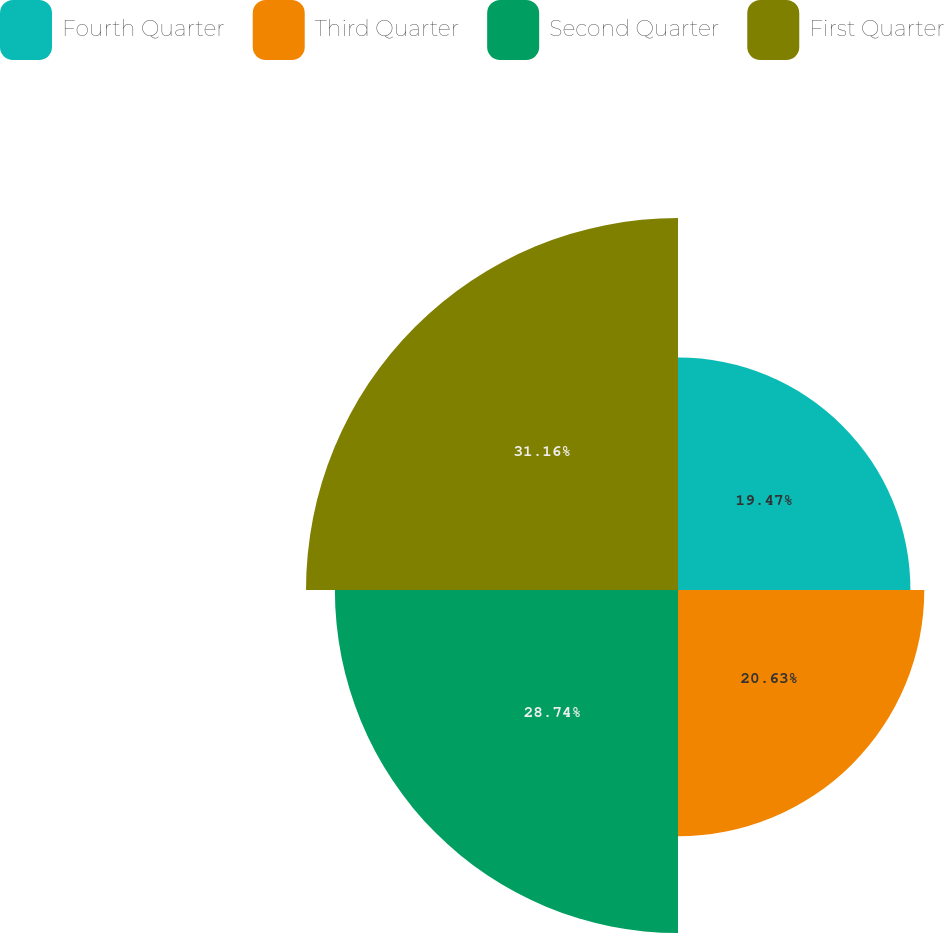Convert chart. <chart><loc_0><loc_0><loc_500><loc_500><pie_chart><fcel>Fourth Quarter<fcel>Third Quarter<fcel>Second Quarter<fcel>First Quarter<nl><fcel>19.47%<fcel>20.63%<fcel>28.74%<fcel>31.16%<nl></chart> 